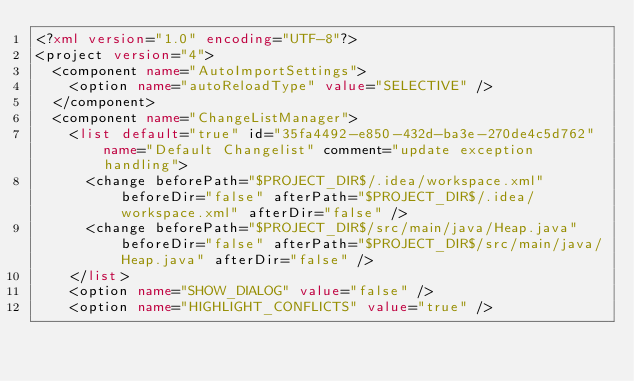<code> <loc_0><loc_0><loc_500><loc_500><_XML_><?xml version="1.0" encoding="UTF-8"?>
<project version="4">
  <component name="AutoImportSettings">
    <option name="autoReloadType" value="SELECTIVE" />
  </component>
  <component name="ChangeListManager">
    <list default="true" id="35fa4492-e850-432d-ba3e-270de4c5d762" name="Default Changelist" comment="update exception handling">
      <change beforePath="$PROJECT_DIR$/.idea/workspace.xml" beforeDir="false" afterPath="$PROJECT_DIR$/.idea/workspace.xml" afterDir="false" />
      <change beforePath="$PROJECT_DIR$/src/main/java/Heap.java" beforeDir="false" afterPath="$PROJECT_DIR$/src/main/java/Heap.java" afterDir="false" />
    </list>
    <option name="SHOW_DIALOG" value="false" />
    <option name="HIGHLIGHT_CONFLICTS" value="true" /></code> 